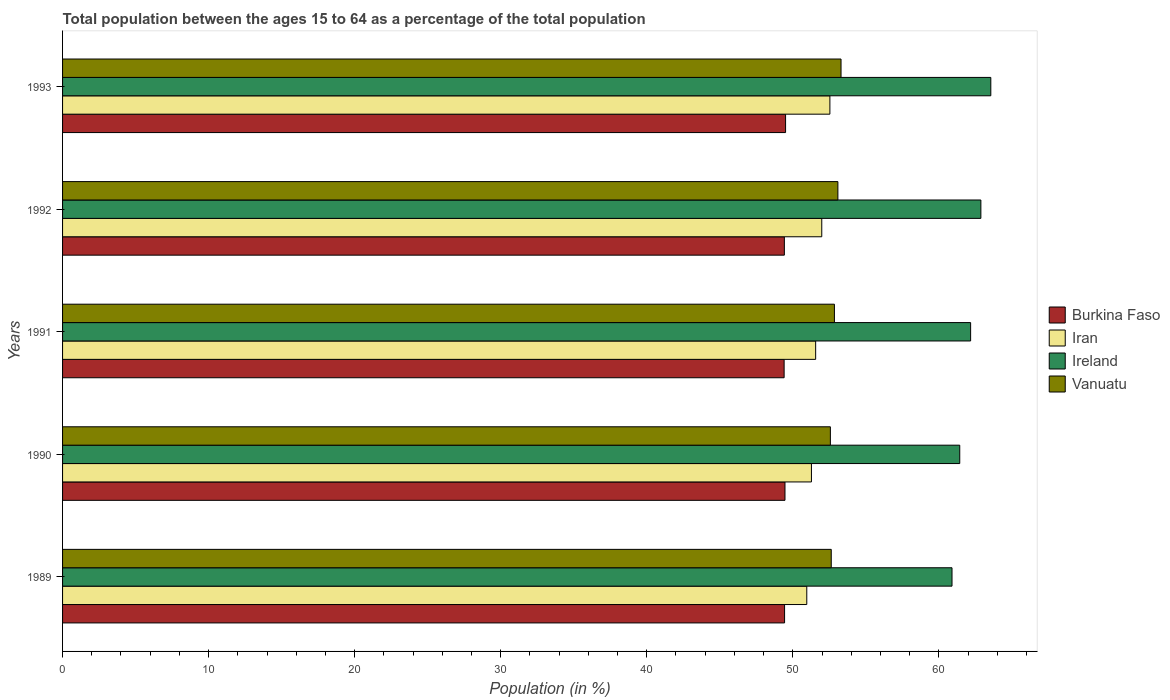How many groups of bars are there?
Offer a very short reply. 5. Are the number of bars per tick equal to the number of legend labels?
Offer a terse response. Yes. Are the number of bars on each tick of the Y-axis equal?
Provide a short and direct response. Yes. What is the percentage of the population ages 15 to 64 in Burkina Faso in 1992?
Offer a very short reply. 49.42. Across all years, what is the maximum percentage of the population ages 15 to 64 in Ireland?
Ensure brevity in your answer.  63.56. Across all years, what is the minimum percentage of the population ages 15 to 64 in Vanuatu?
Your answer should be very brief. 52.57. In which year was the percentage of the population ages 15 to 64 in Vanuatu minimum?
Provide a succinct answer. 1990. What is the total percentage of the population ages 15 to 64 in Burkina Faso in the graph?
Your answer should be compact. 247.23. What is the difference between the percentage of the population ages 15 to 64 in Vanuatu in 1990 and that in 1991?
Your answer should be very brief. -0.28. What is the difference between the percentage of the population ages 15 to 64 in Iran in 1990 and the percentage of the population ages 15 to 64 in Burkina Faso in 1993?
Offer a terse response. 1.77. What is the average percentage of the population ages 15 to 64 in Ireland per year?
Offer a very short reply. 62.19. In the year 1990, what is the difference between the percentage of the population ages 15 to 64 in Ireland and percentage of the population ages 15 to 64 in Vanuatu?
Keep it short and to the point. 8.86. What is the ratio of the percentage of the population ages 15 to 64 in Burkina Faso in 1992 to that in 1993?
Offer a very short reply. 1. What is the difference between the highest and the second highest percentage of the population ages 15 to 64 in Burkina Faso?
Provide a short and direct response. 0.04. What is the difference between the highest and the lowest percentage of the population ages 15 to 64 in Iran?
Provide a short and direct response. 1.58. In how many years, is the percentage of the population ages 15 to 64 in Iran greater than the average percentage of the population ages 15 to 64 in Iran taken over all years?
Provide a short and direct response. 2. Is the sum of the percentage of the population ages 15 to 64 in Vanuatu in 1990 and 1991 greater than the maximum percentage of the population ages 15 to 64 in Burkina Faso across all years?
Make the answer very short. Yes. What does the 4th bar from the top in 1989 represents?
Your answer should be very brief. Burkina Faso. What does the 2nd bar from the bottom in 1990 represents?
Your response must be concise. Iran. How many bars are there?
Offer a very short reply. 20. Does the graph contain grids?
Offer a very short reply. No. How are the legend labels stacked?
Your answer should be very brief. Vertical. What is the title of the graph?
Ensure brevity in your answer.  Total population between the ages 15 to 64 as a percentage of the total population. Does "Costa Rica" appear as one of the legend labels in the graph?
Ensure brevity in your answer.  No. What is the Population (in %) of Burkina Faso in 1989?
Keep it short and to the point. 49.44. What is the Population (in %) in Iran in 1989?
Your answer should be very brief. 50.96. What is the Population (in %) of Ireland in 1989?
Your answer should be compact. 60.9. What is the Population (in %) in Vanuatu in 1989?
Your answer should be compact. 52.63. What is the Population (in %) of Burkina Faso in 1990?
Your response must be concise. 49.46. What is the Population (in %) in Iran in 1990?
Give a very brief answer. 51.27. What is the Population (in %) of Ireland in 1990?
Give a very brief answer. 61.43. What is the Population (in %) of Vanuatu in 1990?
Provide a short and direct response. 52.57. What is the Population (in %) in Burkina Faso in 1991?
Ensure brevity in your answer.  49.41. What is the Population (in %) of Iran in 1991?
Your answer should be very brief. 51.56. What is the Population (in %) of Ireland in 1991?
Offer a terse response. 62.17. What is the Population (in %) in Vanuatu in 1991?
Your response must be concise. 52.85. What is the Population (in %) of Burkina Faso in 1992?
Provide a short and direct response. 49.42. What is the Population (in %) in Iran in 1992?
Provide a short and direct response. 51.98. What is the Population (in %) in Ireland in 1992?
Provide a short and direct response. 62.88. What is the Population (in %) in Vanuatu in 1992?
Your response must be concise. 53.09. What is the Population (in %) in Burkina Faso in 1993?
Provide a short and direct response. 49.5. What is the Population (in %) in Iran in 1993?
Make the answer very short. 52.54. What is the Population (in %) in Ireland in 1993?
Give a very brief answer. 63.56. What is the Population (in %) of Vanuatu in 1993?
Provide a succinct answer. 53.3. Across all years, what is the maximum Population (in %) in Burkina Faso?
Keep it short and to the point. 49.5. Across all years, what is the maximum Population (in %) of Iran?
Your answer should be very brief. 52.54. Across all years, what is the maximum Population (in %) of Ireland?
Make the answer very short. 63.56. Across all years, what is the maximum Population (in %) of Vanuatu?
Make the answer very short. 53.3. Across all years, what is the minimum Population (in %) in Burkina Faso?
Make the answer very short. 49.41. Across all years, what is the minimum Population (in %) of Iran?
Offer a very short reply. 50.96. Across all years, what is the minimum Population (in %) of Ireland?
Give a very brief answer. 60.9. Across all years, what is the minimum Population (in %) of Vanuatu?
Keep it short and to the point. 52.57. What is the total Population (in %) in Burkina Faso in the graph?
Your answer should be very brief. 247.23. What is the total Population (in %) in Iran in the graph?
Keep it short and to the point. 258.32. What is the total Population (in %) in Ireland in the graph?
Your response must be concise. 310.94. What is the total Population (in %) in Vanuatu in the graph?
Provide a short and direct response. 264.44. What is the difference between the Population (in %) of Burkina Faso in 1989 and that in 1990?
Make the answer very short. -0.03. What is the difference between the Population (in %) of Iran in 1989 and that in 1990?
Your answer should be very brief. -0.32. What is the difference between the Population (in %) in Ireland in 1989 and that in 1990?
Your answer should be compact. -0.53. What is the difference between the Population (in %) in Burkina Faso in 1989 and that in 1991?
Ensure brevity in your answer.  0.03. What is the difference between the Population (in %) in Iran in 1989 and that in 1991?
Your answer should be compact. -0.61. What is the difference between the Population (in %) of Ireland in 1989 and that in 1991?
Give a very brief answer. -1.27. What is the difference between the Population (in %) in Vanuatu in 1989 and that in 1991?
Ensure brevity in your answer.  -0.22. What is the difference between the Population (in %) in Burkina Faso in 1989 and that in 1992?
Give a very brief answer. 0.01. What is the difference between the Population (in %) in Iran in 1989 and that in 1992?
Ensure brevity in your answer.  -1.03. What is the difference between the Population (in %) of Ireland in 1989 and that in 1992?
Provide a short and direct response. -1.98. What is the difference between the Population (in %) in Vanuatu in 1989 and that in 1992?
Your answer should be very brief. -0.45. What is the difference between the Population (in %) of Burkina Faso in 1989 and that in 1993?
Ensure brevity in your answer.  -0.07. What is the difference between the Population (in %) in Iran in 1989 and that in 1993?
Your answer should be very brief. -1.58. What is the difference between the Population (in %) in Ireland in 1989 and that in 1993?
Provide a short and direct response. -2.66. What is the difference between the Population (in %) of Vanuatu in 1989 and that in 1993?
Your answer should be compact. -0.67. What is the difference between the Population (in %) in Burkina Faso in 1990 and that in 1991?
Your answer should be compact. 0.06. What is the difference between the Population (in %) in Iran in 1990 and that in 1991?
Ensure brevity in your answer.  -0.29. What is the difference between the Population (in %) of Ireland in 1990 and that in 1991?
Give a very brief answer. -0.74. What is the difference between the Population (in %) of Vanuatu in 1990 and that in 1991?
Your response must be concise. -0.28. What is the difference between the Population (in %) in Burkina Faso in 1990 and that in 1992?
Offer a very short reply. 0.04. What is the difference between the Population (in %) of Iran in 1990 and that in 1992?
Give a very brief answer. -0.71. What is the difference between the Population (in %) in Ireland in 1990 and that in 1992?
Keep it short and to the point. -1.45. What is the difference between the Population (in %) of Vanuatu in 1990 and that in 1992?
Your response must be concise. -0.51. What is the difference between the Population (in %) of Burkina Faso in 1990 and that in 1993?
Provide a succinct answer. -0.04. What is the difference between the Population (in %) of Iran in 1990 and that in 1993?
Your answer should be very brief. -1.26. What is the difference between the Population (in %) in Ireland in 1990 and that in 1993?
Your answer should be compact. -2.13. What is the difference between the Population (in %) in Vanuatu in 1990 and that in 1993?
Ensure brevity in your answer.  -0.73. What is the difference between the Population (in %) in Burkina Faso in 1991 and that in 1992?
Provide a short and direct response. -0.02. What is the difference between the Population (in %) of Iran in 1991 and that in 1992?
Offer a terse response. -0.42. What is the difference between the Population (in %) in Ireland in 1991 and that in 1992?
Ensure brevity in your answer.  -0.7. What is the difference between the Population (in %) of Vanuatu in 1991 and that in 1992?
Provide a short and direct response. -0.24. What is the difference between the Population (in %) in Burkina Faso in 1991 and that in 1993?
Your answer should be compact. -0.1. What is the difference between the Population (in %) in Iran in 1991 and that in 1993?
Your answer should be compact. -0.97. What is the difference between the Population (in %) in Ireland in 1991 and that in 1993?
Keep it short and to the point. -1.38. What is the difference between the Population (in %) of Vanuatu in 1991 and that in 1993?
Ensure brevity in your answer.  -0.45. What is the difference between the Population (in %) of Burkina Faso in 1992 and that in 1993?
Provide a succinct answer. -0.08. What is the difference between the Population (in %) of Iran in 1992 and that in 1993?
Provide a succinct answer. -0.56. What is the difference between the Population (in %) in Ireland in 1992 and that in 1993?
Your answer should be very brief. -0.68. What is the difference between the Population (in %) in Vanuatu in 1992 and that in 1993?
Ensure brevity in your answer.  -0.22. What is the difference between the Population (in %) in Burkina Faso in 1989 and the Population (in %) in Iran in 1990?
Provide a short and direct response. -1.84. What is the difference between the Population (in %) of Burkina Faso in 1989 and the Population (in %) of Ireland in 1990?
Your answer should be very brief. -11.99. What is the difference between the Population (in %) of Burkina Faso in 1989 and the Population (in %) of Vanuatu in 1990?
Provide a short and direct response. -3.14. What is the difference between the Population (in %) in Iran in 1989 and the Population (in %) in Ireland in 1990?
Make the answer very short. -10.47. What is the difference between the Population (in %) in Iran in 1989 and the Population (in %) in Vanuatu in 1990?
Your response must be concise. -1.62. What is the difference between the Population (in %) in Ireland in 1989 and the Population (in %) in Vanuatu in 1990?
Your response must be concise. 8.33. What is the difference between the Population (in %) of Burkina Faso in 1989 and the Population (in %) of Iran in 1991?
Ensure brevity in your answer.  -2.13. What is the difference between the Population (in %) in Burkina Faso in 1989 and the Population (in %) in Ireland in 1991?
Provide a short and direct response. -12.74. What is the difference between the Population (in %) of Burkina Faso in 1989 and the Population (in %) of Vanuatu in 1991?
Offer a terse response. -3.41. What is the difference between the Population (in %) in Iran in 1989 and the Population (in %) in Ireland in 1991?
Ensure brevity in your answer.  -11.22. What is the difference between the Population (in %) in Iran in 1989 and the Population (in %) in Vanuatu in 1991?
Offer a very short reply. -1.89. What is the difference between the Population (in %) of Ireland in 1989 and the Population (in %) of Vanuatu in 1991?
Provide a short and direct response. 8.05. What is the difference between the Population (in %) of Burkina Faso in 1989 and the Population (in %) of Iran in 1992?
Keep it short and to the point. -2.55. What is the difference between the Population (in %) of Burkina Faso in 1989 and the Population (in %) of Ireland in 1992?
Make the answer very short. -13.44. What is the difference between the Population (in %) in Burkina Faso in 1989 and the Population (in %) in Vanuatu in 1992?
Keep it short and to the point. -3.65. What is the difference between the Population (in %) in Iran in 1989 and the Population (in %) in Ireland in 1992?
Keep it short and to the point. -11.92. What is the difference between the Population (in %) in Iran in 1989 and the Population (in %) in Vanuatu in 1992?
Provide a succinct answer. -2.13. What is the difference between the Population (in %) of Ireland in 1989 and the Population (in %) of Vanuatu in 1992?
Your response must be concise. 7.81. What is the difference between the Population (in %) of Burkina Faso in 1989 and the Population (in %) of Iran in 1993?
Offer a very short reply. -3.1. What is the difference between the Population (in %) of Burkina Faso in 1989 and the Population (in %) of Ireland in 1993?
Offer a terse response. -14.12. What is the difference between the Population (in %) of Burkina Faso in 1989 and the Population (in %) of Vanuatu in 1993?
Offer a very short reply. -3.87. What is the difference between the Population (in %) in Iran in 1989 and the Population (in %) in Ireland in 1993?
Offer a terse response. -12.6. What is the difference between the Population (in %) of Iran in 1989 and the Population (in %) of Vanuatu in 1993?
Make the answer very short. -2.35. What is the difference between the Population (in %) in Ireland in 1989 and the Population (in %) in Vanuatu in 1993?
Your response must be concise. 7.6. What is the difference between the Population (in %) of Burkina Faso in 1990 and the Population (in %) of Iran in 1991?
Your response must be concise. -2.1. What is the difference between the Population (in %) of Burkina Faso in 1990 and the Population (in %) of Ireland in 1991?
Make the answer very short. -12.71. What is the difference between the Population (in %) of Burkina Faso in 1990 and the Population (in %) of Vanuatu in 1991?
Make the answer very short. -3.38. What is the difference between the Population (in %) in Iran in 1990 and the Population (in %) in Ireland in 1991?
Provide a short and direct response. -10.9. What is the difference between the Population (in %) of Iran in 1990 and the Population (in %) of Vanuatu in 1991?
Provide a short and direct response. -1.57. What is the difference between the Population (in %) in Ireland in 1990 and the Population (in %) in Vanuatu in 1991?
Make the answer very short. 8.58. What is the difference between the Population (in %) of Burkina Faso in 1990 and the Population (in %) of Iran in 1992?
Make the answer very short. -2.52. What is the difference between the Population (in %) in Burkina Faso in 1990 and the Population (in %) in Ireland in 1992?
Your answer should be very brief. -13.41. What is the difference between the Population (in %) of Burkina Faso in 1990 and the Population (in %) of Vanuatu in 1992?
Offer a terse response. -3.62. What is the difference between the Population (in %) of Iran in 1990 and the Population (in %) of Ireland in 1992?
Offer a very short reply. -11.6. What is the difference between the Population (in %) of Iran in 1990 and the Population (in %) of Vanuatu in 1992?
Provide a succinct answer. -1.81. What is the difference between the Population (in %) in Ireland in 1990 and the Population (in %) in Vanuatu in 1992?
Offer a very short reply. 8.34. What is the difference between the Population (in %) in Burkina Faso in 1990 and the Population (in %) in Iran in 1993?
Your answer should be very brief. -3.07. What is the difference between the Population (in %) in Burkina Faso in 1990 and the Population (in %) in Ireland in 1993?
Offer a terse response. -14.09. What is the difference between the Population (in %) in Burkina Faso in 1990 and the Population (in %) in Vanuatu in 1993?
Ensure brevity in your answer.  -3.84. What is the difference between the Population (in %) in Iran in 1990 and the Population (in %) in Ireland in 1993?
Your response must be concise. -12.28. What is the difference between the Population (in %) in Iran in 1990 and the Population (in %) in Vanuatu in 1993?
Provide a succinct answer. -2.03. What is the difference between the Population (in %) of Ireland in 1990 and the Population (in %) of Vanuatu in 1993?
Offer a terse response. 8.13. What is the difference between the Population (in %) of Burkina Faso in 1991 and the Population (in %) of Iran in 1992?
Make the answer very short. -2.58. What is the difference between the Population (in %) in Burkina Faso in 1991 and the Population (in %) in Ireland in 1992?
Keep it short and to the point. -13.47. What is the difference between the Population (in %) in Burkina Faso in 1991 and the Population (in %) in Vanuatu in 1992?
Provide a succinct answer. -3.68. What is the difference between the Population (in %) of Iran in 1991 and the Population (in %) of Ireland in 1992?
Ensure brevity in your answer.  -11.31. What is the difference between the Population (in %) of Iran in 1991 and the Population (in %) of Vanuatu in 1992?
Keep it short and to the point. -1.52. What is the difference between the Population (in %) of Ireland in 1991 and the Population (in %) of Vanuatu in 1992?
Ensure brevity in your answer.  9.09. What is the difference between the Population (in %) of Burkina Faso in 1991 and the Population (in %) of Iran in 1993?
Make the answer very short. -3.13. What is the difference between the Population (in %) of Burkina Faso in 1991 and the Population (in %) of Ireland in 1993?
Provide a short and direct response. -14.15. What is the difference between the Population (in %) in Burkina Faso in 1991 and the Population (in %) in Vanuatu in 1993?
Your answer should be compact. -3.9. What is the difference between the Population (in %) in Iran in 1991 and the Population (in %) in Ireland in 1993?
Offer a terse response. -11.99. What is the difference between the Population (in %) in Iran in 1991 and the Population (in %) in Vanuatu in 1993?
Give a very brief answer. -1.74. What is the difference between the Population (in %) in Ireland in 1991 and the Population (in %) in Vanuatu in 1993?
Give a very brief answer. 8.87. What is the difference between the Population (in %) in Burkina Faso in 1992 and the Population (in %) in Iran in 1993?
Give a very brief answer. -3.12. What is the difference between the Population (in %) of Burkina Faso in 1992 and the Population (in %) of Ireland in 1993?
Provide a succinct answer. -14.14. What is the difference between the Population (in %) in Burkina Faso in 1992 and the Population (in %) in Vanuatu in 1993?
Provide a short and direct response. -3.88. What is the difference between the Population (in %) in Iran in 1992 and the Population (in %) in Ireland in 1993?
Provide a short and direct response. -11.57. What is the difference between the Population (in %) of Iran in 1992 and the Population (in %) of Vanuatu in 1993?
Make the answer very short. -1.32. What is the difference between the Population (in %) in Ireland in 1992 and the Population (in %) in Vanuatu in 1993?
Make the answer very short. 9.57. What is the average Population (in %) in Burkina Faso per year?
Your response must be concise. 49.45. What is the average Population (in %) in Iran per year?
Make the answer very short. 51.66. What is the average Population (in %) in Ireland per year?
Offer a very short reply. 62.19. What is the average Population (in %) of Vanuatu per year?
Ensure brevity in your answer.  52.89. In the year 1989, what is the difference between the Population (in %) in Burkina Faso and Population (in %) in Iran?
Provide a short and direct response. -1.52. In the year 1989, what is the difference between the Population (in %) in Burkina Faso and Population (in %) in Ireland?
Offer a very short reply. -11.46. In the year 1989, what is the difference between the Population (in %) in Burkina Faso and Population (in %) in Vanuatu?
Offer a very short reply. -3.2. In the year 1989, what is the difference between the Population (in %) of Iran and Population (in %) of Ireland?
Keep it short and to the point. -9.94. In the year 1989, what is the difference between the Population (in %) in Iran and Population (in %) in Vanuatu?
Offer a very short reply. -1.68. In the year 1989, what is the difference between the Population (in %) in Ireland and Population (in %) in Vanuatu?
Your response must be concise. 8.27. In the year 1990, what is the difference between the Population (in %) in Burkina Faso and Population (in %) in Iran?
Offer a very short reply. -1.81. In the year 1990, what is the difference between the Population (in %) in Burkina Faso and Population (in %) in Ireland?
Offer a terse response. -11.97. In the year 1990, what is the difference between the Population (in %) in Burkina Faso and Population (in %) in Vanuatu?
Ensure brevity in your answer.  -3.11. In the year 1990, what is the difference between the Population (in %) in Iran and Population (in %) in Ireland?
Provide a short and direct response. -10.15. In the year 1990, what is the difference between the Population (in %) in Iran and Population (in %) in Vanuatu?
Offer a very short reply. -1.3. In the year 1990, what is the difference between the Population (in %) in Ireland and Population (in %) in Vanuatu?
Provide a succinct answer. 8.86. In the year 1991, what is the difference between the Population (in %) of Burkina Faso and Population (in %) of Iran?
Your answer should be very brief. -2.16. In the year 1991, what is the difference between the Population (in %) in Burkina Faso and Population (in %) in Ireland?
Provide a short and direct response. -12.77. In the year 1991, what is the difference between the Population (in %) in Burkina Faso and Population (in %) in Vanuatu?
Give a very brief answer. -3.44. In the year 1991, what is the difference between the Population (in %) of Iran and Population (in %) of Ireland?
Your answer should be compact. -10.61. In the year 1991, what is the difference between the Population (in %) of Iran and Population (in %) of Vanuatu?
Your response must be concise. -1.28. In the year 1991, what is the difference between the Population (in %) of Ireland and Population (in %) of Vanuatu?
Ensure brevity in your answer.  9.33. In the year 1992, what is the difference between the Population (in %) of Burkina Faso and Population (in %) of Iran?
Your answer should be compact. -2.56. In the year 1992, what is the difference between the Population (in %) in Burkina Faso and Population (in %) in Ireland?
Ensure brevity in your answer.  -13.46. In the year 1992, what is the difference between the Population (in %) of Burkina Faso and Population (in %) of Vanuatu?
Your answer should be very brief. -3.66. In the year 1992, what is the difference between the Population (in %) in Iran and Population (in %) in Ireland?
Ensure brevity in your answer.  -10.89. In the year 1992, what is the difference between the Population (in %) of Iran and Population (in %) of Vanuatu?
Give a very brief answer. -1.1. In the year 1992, what is the difference between the Population (in %) of Ireland and Population (in %) of Vanuatu?
Ensure brevity in your answer.  9.79. In the year 1993, what is the difference between the Population (in %) of Burkina Faso and Population (in %) of Iran?
Offer a very short reply. -3.03. In the year 1993, what is the difference between the Population (in %) in Burkina Faso and Population (in %) in Ireland?
Your response must be concise. -14.05. In the year 1993, what is the difference between the Population (in %) of Burkina Faso and Population (in %) of Vanuatu?
Ensure brevity in your answer.  -3.8. In the year 1993, what is the difference between the Population (in %) in Iran and Population (in %) in Ireland?
Your response must be concise. -11.02. In the year 1993, what is the difference between the Population (in %) of Iran and Population (in %) of Vanuatu?
Your answer should be very brief. -0.76. In the year 1993, what is the difference between the Population (in %) in Ireland and Population (in %) in Vanuatu?
Provide a short and direct response. 10.26. What is the ratio of the Population (in %) in Iran in 1989 to that in 1990?
Give a very brief answer. 0.99. What is the ratio of the Population (in %) in Ireland in 1989 to that in 1990?
Your answer should be compact. 0.99. What is the ratio of the Population (in %) of Vanuatu in 1989 to that in 1990?
Your answer should be very brief. 1. What is the ratio of the Population (in %) of Iran in 1989 to that in 1991?
Keep it short and to the point. 0.99. What is the ratio of the Population (in %) of Ireland in 1989 to that in 1991?
Your response must be concise. 0.98. What is the ratio of the Population (in %) in Vanuatu in 1989 to that in 1991?
Your response must be concise. 1. What is the ratio of the Population (in %) in Iran in 1989 to that in 1992?
Your answer should be very brief. 0.98. What is the ratio of the Population (in %) in Ireland in 1989 to that in 1992?
Make the answer very short. 0.97. What is the ratio of the Population (in %) in Burkina Faso in 1989 to that in 1993?
Your answer should be compact. 1. What is the ratio of the Population (in %) in Iran in 1989 to that in 1993?
Provide a succinct answer. 0.97. What is the ratio of the Population (in %) of Ireland in 1989 to that in 1993?
Ensure brevity in your answer.  0.96. What is the ratio of the Population (in %) in Vanuatu in 1989 to that in 1993?
Give a very brief answer. 0.99. What is the ratio of the Population (in %) of Iran in 1990 to that in 1991?
Your answer should be compact. 0.99. What is the ratio of the Population (in %) in Ireland in 1990 to that in 1991?
Offer a very short reply. 0.99. What is the ratio of the Population (in %) of Burkina Faso in 1990 to that in 1992?
Your answer should be compact. 1. What is the ratio of the Population (in %) in Iran in 1990 to that in 1992?
Your answer should be very brief. 0.99. What is the ratio of the Population (in %) in Ireland in 1990 to that in 1992?
Provide a succinct answer. 0.98. What is the ratio of the Population (in %) of Vanuatu in 1990 to that in 1992?
Offer a very short reply. 0.99. What is the ratio of the Population (in %) in Iran in 1990 to that in 1993?
Provide a short and direct response. 0.98. What is the ratio of the Population (in %) of Ireland in 1990 to that in 1993?
Provide a succinct answer. 0.97. What is the ratio of the Population (in %) of Vanuatu in 1990 to that in 1993?
Offer a very short reply. 0.99. What is the ratio of the Population (in %) in Ireland in 1991 to that in 1992?
Keep it short and to the point. 0.99. What is the ratio of the Population (in %) of Vanuatu in 1991 to that in 1992?
Offer a terse response. 1. What is the ratio of the Population (in %) of Iran in 1991 to that in 1993?
Your response must be concise. 0.98. What is the ratio of the Population (in %) of Ireland in 1991 to that in 1993?
Keep it short and to the point. 0.98. What is the ratio of the Population (in %) of Burkina Faso in 1992 to that in 1993?
Your answer should be compact. 1. What is the ratio of the Population (in %) in Iran in 1992 to that in 1993?
Your response must be concise. 0.99. What is the ratio of the Population (in %) of Ireland in 1992 to that in 1993?
Offer a very short reply. 0.99. What is the difference between the highest and the second highest Population (in %) of Burkina Faso?
Provide a short and direct response. 0.04. What is the difference between the highest and the second highest Population (in %) in Iran?
Provide a short and direct response. 0.56. What is the difference between the highest and the second highest Population (in %) of Ireland?
Offer a very short reply. 0.68. What is the difference between the highest and the second highest Population (in %) of Vanuatu?
Offer a terse response. 0.22. What is the difference between the highest and the lowest Population (in %) in Burkina Faso?
Keep it short and to the point. 0.1. What is the difference between the highest and the lowest Population (in %) of Iran?
Your answer should be compact. 1.58. What is the difference between the highest and the lowest Population (in %) of Ireland?
Your answer should be very brief. 2.66. What is the difference between the highest and the lowest Population (in %) in Vanuatu?
Offer a terse response. 0.73. 